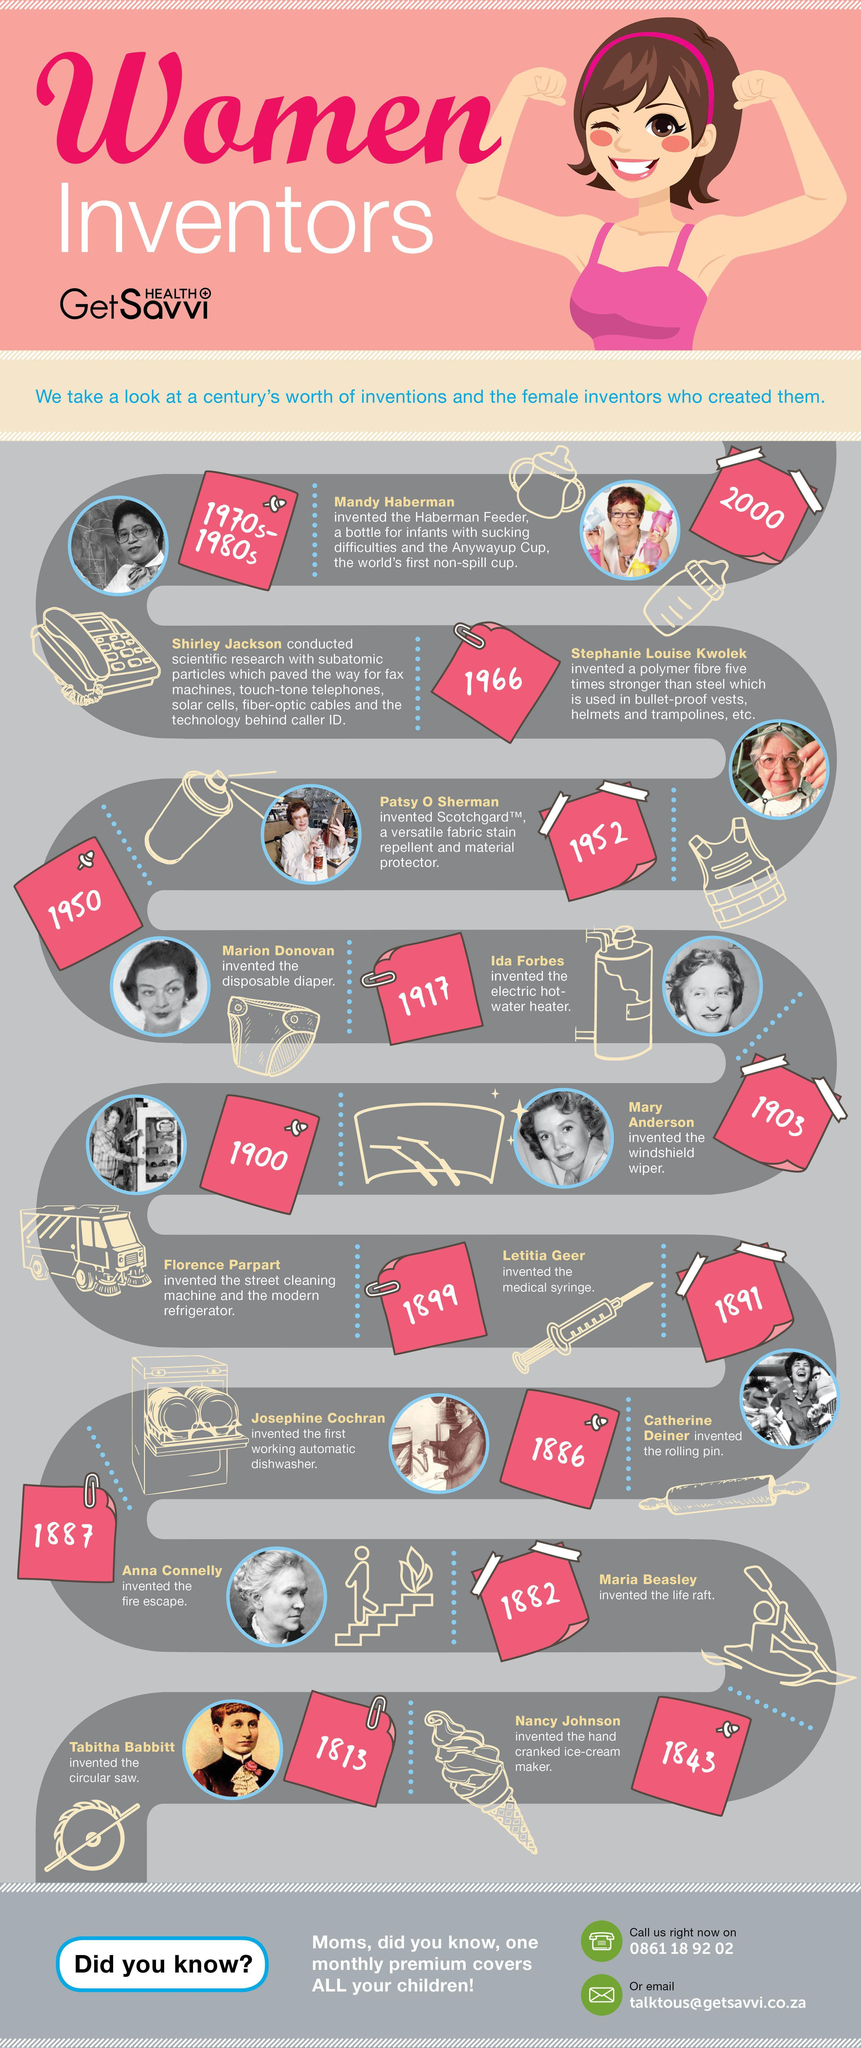Outline some significant characteristics in this image. Letitia Geer invented the medical syringe. Nancy Johnson is credited with inventing the hand-cranked ice-cream maker. Florence Parpart invented the street cleaning machine and the modern refrigerator in 1900. The electric hot-water heater was invented by Ida Forbes. Shirley Jackson's research paved the way for the development of solar cells, fiber-optic cables, fax machines, and caller-id technology, and she is widely recognized for her groundbreaking contributions to the field. 